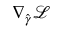<formula> <loc_0><loc_0><loc_500><loc_500>\nabla _ { \hat { \gamma } } \mathcal { L }</formula> 